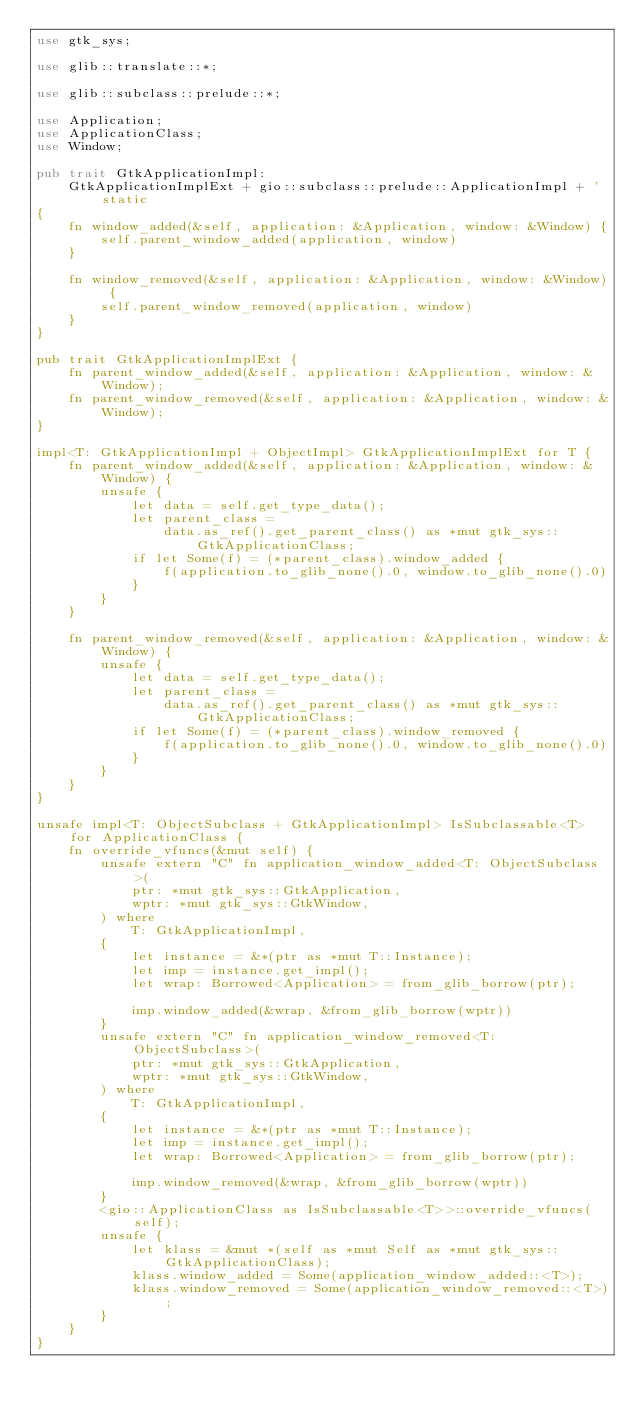<code> <loc_0><loc_0><loc_500><loc_500><_Rust_>use gtk_sys;

use glib::translate::*;

use glib::subclass::prelude::*;

use Application;
use ApplicationClass;
use Window;

pub trait GtkApplicationImpl:
    GtkApplicationImplExt + gio::subclass::prelude::ApplicationImpl + 'static
{
    fn window_added(&self, application: &Application, window: &Window) {
        self.parent_window_added(application, window)
    }

    fn window_removed(&self, application: &Application, window: &Window) {
        self.parent_window_removed(application, window)
    }
}

pub trait GtkApplicationImplExt {
    fn parent_window_added(&self, application: &Application, window: &Window);
    fn parent_window_removed(&self, application: &Application, window: &Window);
}

impl<T: GtkApplicationImpl + ObjectImpl> GtkApplicationImplExt for T {
    fn parent_window_added(&self, application: &Application, window: &Window) {
        unsafe {
            let data = self.get_type_data();
            let parent_class =
                data.as_ref().get_parent_class() as *mut gtk_sys::GtkApplicationClass;
            if let Some(f) = (*parent_class).window_added {
                f(application.to_glib_none().0, window.to_glib_none().0)
            }
        }
    }

    fn parent_window_removed(&self, application: &Application, window: &Window) {
        unsafe {
            let data = self.get_type_data();
            let parent_class =
                data.as_ref().get_parent_class() as *mut gtk_sys::GtkApplicationClass;
            if let Some(f) = (*parent_class).window_removed {
                f(application.to_glib_none().0, window.to_glib_none().0)
            }
        }
    }
}

unsafe impl<T: ObjectSubclass + GtkApplicationImpl> IsSubclassable<T> for ApplicationClass {
    fn override_vfuncs(&mut self) {
        unsafe extern "C" fn application_window_added<T: ObjectSubclass>(
            ptr: *mut gtk_sys::GtkApplication,
            wptr: *mut gtk_sys::GtkWindow,
        ) where
            T: GtkApplicationImpl,
        {
            let instance = &*(ptr as *mut T::Instance);
            let imp = instance.get_impl();
            let wrap: Borrowed<Application> = from_glib_borrow(ptr);

            imp.window_added(&wrap, &from_glib_borrow(wptr))
        }
        unsafe extern "C" fn application_window_removed<T: ObjectSubclass>(
            ptr: *mut gtk_sys::GtkApplication,
            wptr: *mut gtk_sys::GtkWindow,
        ) where
            T: GtkApplicationImpl,
        {
            let instance = &*(ptr as *mut T::Instance);
            let imp = instance.get_impl();
            let wrap: Borrowed<Application> = from_glib_borrow(ptr);

            imp.window_removed(&wrap, &from_glib_borrow(wptr))
        }
        <gio::ApplicationClass as IsSubclassable<T>>::override_vfuncs(self);
        unsafe {
            let klass = &mut *(self as *mut Self as *mut gtk_sys::GtkApplicationClass);
            klass.window_added = Some(application_window_added::<T>);
            klass.window_removed = Some(application_window_removed::<T>);
        }
    }
}
</code> 